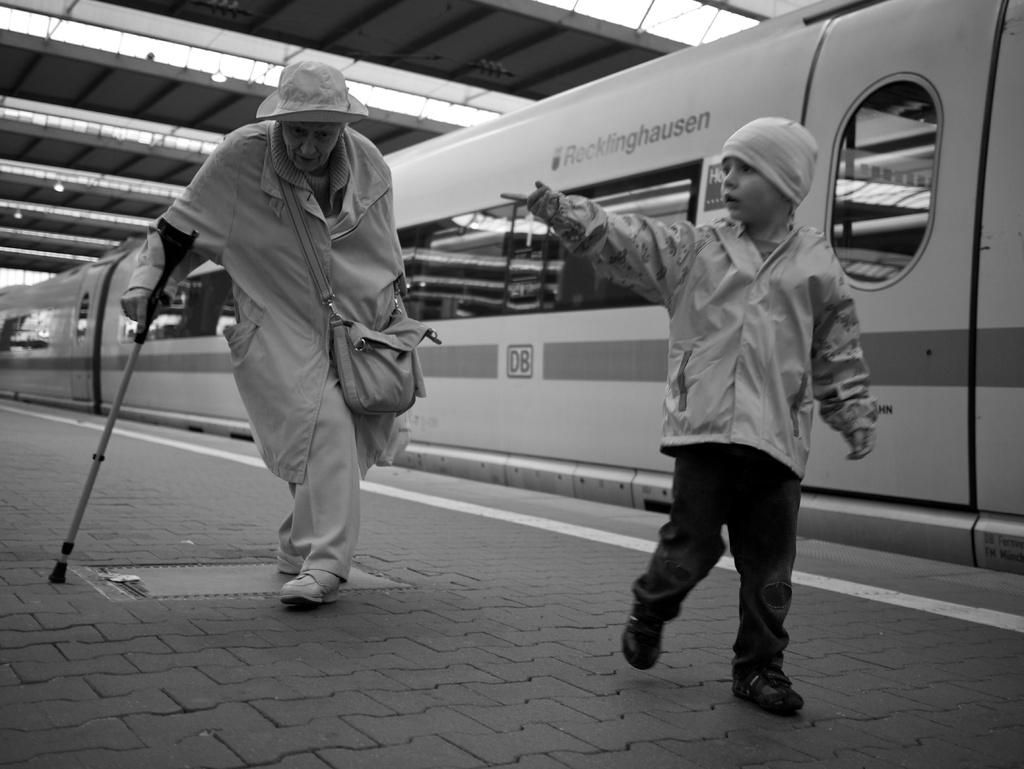<image>
Relay a brief, clear account of the picture shown. A train that says ROCKFINDHAUSEN ON IT.A boy pointing his finger. 